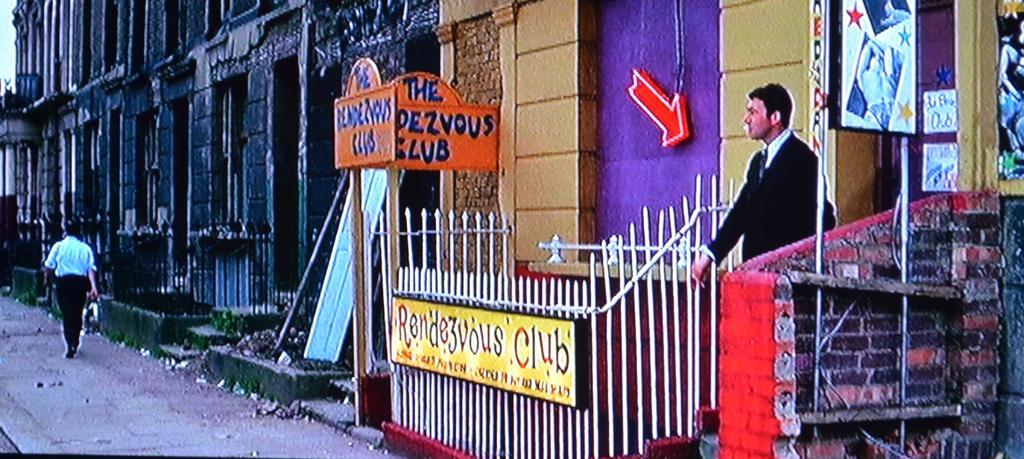Can you describe this image briefly? In this image I can see two persons. In front the person is wearing black color blazer and white color shirt and I can also see the fencing and the stall. In the background I can see the building and the sky is in white color. 